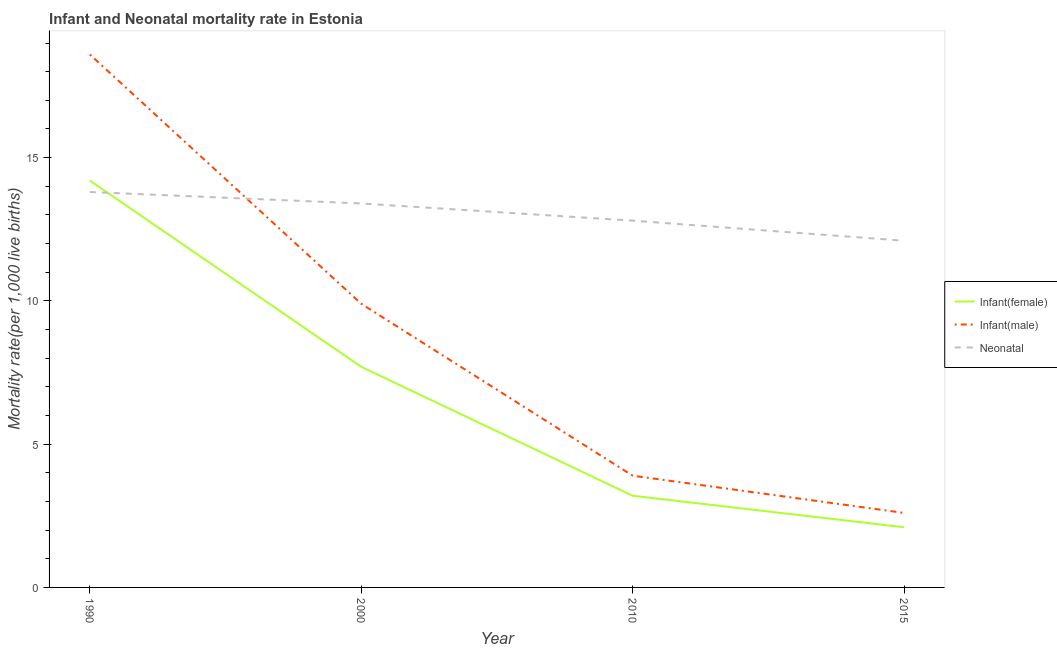What is the neonatal mortality rate in 2010?
Give a very brief answer. 12.8. In which year was the neonatal mortality rate maximum?
Provide a succinct answer. 1990. In which year was the infant mortality rate(male) minimum?
Offer a very short reply. 2015. What is the total neonatal mortality rate in the graph?
Make the answer very short. 52.1. What is the difference between the infant mortality rate(female) in 1990 and that in 2010?
Offer a terse response. 11. What is the difference between the infant mortality rate(male) in 2015 and the neonatal mortality rate in 2010?
Provide a succinct answer. -10.2. What is the average infant mortality rate(female) per year?
Provide a succinct answer. 6.8. In the year 2010, what is the difference between the neonatal mortality rate and infant mortality rate(male)?
Your response must be concise. 8.9. What is the ratio of the infant mortality rate(female) in 1990 to that in 2000?
Ensure brevity in your answer.  1.84. Is the infant mortality rate(male) in 2010 less than that in 2015?
Your answer should be compact. No. What is the difference between the highest and the second highest neonatal mortality rate?
Your answer should be compact. 0.4. What is the difference between the highest and the lowest infant mortality rate(male)?
Offer a very short reply. 16. In how many years, is the infant mortality rate(female) greater than the average infant mortality rate(female) taken over all years?
Give a very brief answer. 2. Is it the case that in every year, the sum of the infant mortality rate(female) and infant mortality rate(male) is greater than the neonatal mortality rate?
Your answer should be very brief. No. Does the infant mortality rate(male) monotonically increase over the years?
Provide a short and direct response. No. How many years are there in the graph?
Give a very brief answer. 4. What is the difference between two consecutive major ticks on the Y-axis?
Make the answer very short. 5. Does the graph contain any zero values?
Ensure brevity in your answer.  No. Does the graph contain grids?
Your answer should be compact. No. How many legend labels are there?
Offer a terse response. 3. What is the title of the graph?
Your answer should be very brief. Infant and Neonatal mortality rate in Estonia. Does "Social Insurance" appear as one of the legend labels in the graph?
Keep it short and to the point. No. What is the label or title of the Y-axis?
Offer a terse response. Mortality rate(per 1,0 live births). What is the Mortality rate(per 1,000 live births) in Infant(female) in 2000?
Keep it short and to the point. 7.7. What is the Mortality rate(per 1,000 live births) of Neonatal  in 2000?
Make the answer very short. 13.4. What is the Mortality rate(per 1,000 live births) of Neonatal  in 2010?
Make the answer very short. 12.8. What is the Mortality rate(per 1,000 live births) in Infant(female) in 2015?
Ensure brevity in your answer.  2.1. Across all years, what is the maximum Mortality rate(per 1,000 live births) of Infant(female)?
Your response must be concise. 14.2. Across all years, what is the minimum Mortality rate(per 1,000 live births) of Infant(male)?
Ensure brevity in your answer.  2.6. What is the total Mortality rate(per 1,000 live births) in Infant(female) in the graph?
Give a very brief answer. 27.2. What is the total Mortality rate(per 1,000 live births) of Neonatal  in the graph?
Your answer should be compact. 52.1. What is the difference between the Mortality rate(per 1,000 live births) in Infant(male) in 1990 and that in 2010?
Ensure brevity in your answer.  14.7. What is the difference between the Mortality rate(per 1,000 live births) of Neonatal  in 1990 and that in 2010?
Provide a short and direct response. 1. What is the difference between the Mortality rate(per 1,000 live births) in Infant(female) in 1990 and that in 2015?
Make the answer very short. 12.1. What is the difference between the Mortality rate(per 1,000 live births) in Neonatal  in 1990 and that in 2015?
Keep it short and to the point. 1.7. What is the difference between the Mortality rate(per 1,000 live births) in Infant(male) in 2000 and that in 2010?
Keep it short and to the point. 6. What is the difference between the Mortality rate(per 1,000 live births) of Neonatal  in 2000 and that in 2015?
Keep it short and to the point. 1.3. What is the difference between the Mortality rate(per 1,000 live births) in Infant(female) in 1990 and the Mortality rate(per 1,000 live births) in Infant(male) in 2010?
Provide a succinct answer. 10.3. What is the difference between the Mortality rate(per 1,000 live births) in Infant(male) in 1990 and the Mortality rate(per 1,000 live births) in Neonatal  in 2010?
Ensure brevity in your answer.  5.8. What is the difference between the Mortality rate(per 1,000 live births) in Infant(female) in 1990 and the Mortality rate(per 1,000 live births) in Infant(male) in 2015?
Give a very brief answer. 11.6. What is the difference between the Mortality rate(per 1,000 live births) of Infant(female) in 1990 and the Mortality rate(per 1,000 live births) of Neonatal  in 2015?
Your answer should be very brief. 2.1. What is the difference between the Mortality rate(per 1,000 live births) in Infant(male) in 1990 and the Mortality rate(per 1,000 live births) in Neonatal  in 2015?
Make the answer very short. 6.5. What is the difference between the Mortality rate(per 1,000 live births) in Infant(female) in 2000 and the Mortality rate(per 1,000 live births) in Neonatal  in 2010?
Make the answer very short. -5.1. What is the difference between the Mortality rate(per 1,000 live births) of Infant(male) in 2000 and the Mortality rate(per 1,000 live births) of Neonatal  in 2010?
Keep it short and to the point. -2.9. What is the difference between the Mortality rate(per 1,000 live births) of Infant(female) in 2000 and the Mortality rate(per 1,000 live births) of Infant(male) in 2015?
Your response must be concise. 5.1. What is the difference between the Mortality rate(per 1,000 live births) of Infant(male) in 2000 and the Mortality rate(per 1,000 live births) of Neonatal  in 2015?
Your response must be concise. -2.2. What is the difference between the Mortality rate(per 1,000 live births) of Infant(female) in 2010 and the Mortality rate(per 1,000 live births) of Neonatal  in 2015?
Offer a terse response. -8.9. What is the difference between the Mortality rate(per 1,000 live births) of Infant(male) in 2010 and the Mortality rate(per 1,000 live births) of Neonatal  in 2015?
Offer a very short reply. -8.2. What is the average Mortality rate(per 1,000 live births) in Infant(female) per year?
Your answer should be compact. 6.8. What is the average Mortality rate(per 1,000 live births) in Infant(male) per year?
Provide a short and direct response. 8.75. What is the average Mortality rate(per 1,000 live births) in Neonatal  per year?
Provide a short and direct response. 13.03. In the year 1990, what is the difference between the Mortality rate(per 1,000 live births) in Infant(female) and Mortality rate(per 1,000 live births) in Neonatal ?
Offer a terse response. 0.4. In the year 2000, what is the difference between the Mortality rate(per 1,000 live births) of Infant(female) and Mortality rate(per 1,000 live births) of Infant(male)?
Provide a succinct answer. -2.2. In the year 2000, what is the difference between the Mortality rate(per 1,000 live births) of Infant(male) and Mortality rate(per 1,000 live births) of Neonatal ?
Your answer should be very brief. -3.5. In the year 2010, what is the difference between the Mortality rate(per 1,000 live births) of Infant(female) and Mortality rate(per 1,000 live births) of Infant(male)?
Give a very brief answer. -0.7. In the year 2010, what is the difference between the Mortality rate(per 1,000 live births) in Infant(female) and Mortality rate(per 1,000 live births) in Neonatal ?
Offer a terse response. -9.6. In the year 2010, what is the difference between the Mortality rate(per 1,000 live births) of Infant(male) and Mortality rate(per 1,000 live births) of Neonatal ?
Provide a short and direct response. -8.9. In the year 2015, what is the difference between the Mortality rate(per 1,000 live births) of Infant(female) and Mortality rate(per 1,000 live births) of Neonatal ?
Your response must be concise. -10. What is the ratio of the Mortality rate(per 1,000 live births) in Infant(female) in 1990 to that in 2000?
Your answer should be compact. 1.84. What is the ratio of the Mortality rate(per 1,000 live births) of Infant(male) in 1990 to that in 2000?
Your answer should be compact. 1.88. What is the ratio of the Mortality rate(per 1,000 live births) in Neonatal  in 1990 to that in 2000?
Ensure brevity in your answer.  1.03. What is the ratio of the Mortality rate(per 1,000 live births) in Infant(female) in 1990 to that in 2010?
Your answer should be very brief. 4.44. What is the ratio of the Mortality rate(per 1,000 live births) in Infant(male) in 1990 to that in 2010?
Offer a very short reply. 4.77. What is the ratio of the Mortality rate(per 1,000 live births) of Neonatal  in 1990 to that in 2010?
Your answer should be compact. 1.08. What is the ratio of the Mortality rate(per 1,000 live births) of Infant(female) in 1990 to that in 2015?
Provide a short and direct response. 6.76. What is the ratio of the Mortality rate(per 1,000 live births) of Infant(male) in 1990 to that in 2015?
Ensure brevity in your answer.  7.15. What is the ratio of the Mortality rate(per 1,000 live births) of Neonatal  in 1990 to that in 2015?
Your answer should be very brief. 1.14. What is the ratio of the Mortality rate(per 1,000 live births) in Infant(female) in 2000 to that in 2010?
Provide a short and direct response. 2.41. What is the ratio of the Mortality rate(per 1,000 live births) of Infant(male) in 2000 to that in 2010?
Your answer should be compact. 2.54. What is the ratio of the Mortality rate(per 1,000 live births) in Neonatal  in 2000 to that in 2010?
Provide a short and direct response. 1.05. What is the ratio of the Mortality rate(per 1,000 live births) in Infant(female) in 2000 to that in 2015?
Provide a succinct answer. 3.67. What is the ratio of the Mortality rate(per 1,000 live births) of Infant(male) in 2000 to that in 2015?
Give a very brief answer. 3.81. What is the ratio of the Mortality rate(per 1,000 live births) of Neonatal  in 2000 to that in 2015?
Provide a succinct answer. 1.11. What is the ratio of the Mortality rate(per 1,000 live births) of Infant(female) in 2010 to that in 2015?
Offer a terse response. 1.52. What is the ratio of the Mortality rate(per 1,000 live births) in Infant(male) in 2010 to that in 2015?
Keep it short and to the point. 1.5. What is the ratio of the Mortality rate(per 1,000 live births) of Neonatal  in 2010 to that in 2015?
Your answer should be compact. 1.06. What is the difference between the highest and the second highest Mortality rate(per 1,000 live births) of Infant(female)?
Give a very brief answer. 6.5. What is the difference between the highest and the second highest Mortality rate(per 1,000 live births) in Infant(male)?
Your response must be concise. 8.7. What is the difference between the highest and the lowest Mortality rate(per 1,000 live births) in Infant(male)?
Ensure brevity in your answer.  16. What is the difference between the highest and the lowest Mortality rate(per 1,000 live births) in Neonatal ?
Your answer should be very brief. 1.7. 